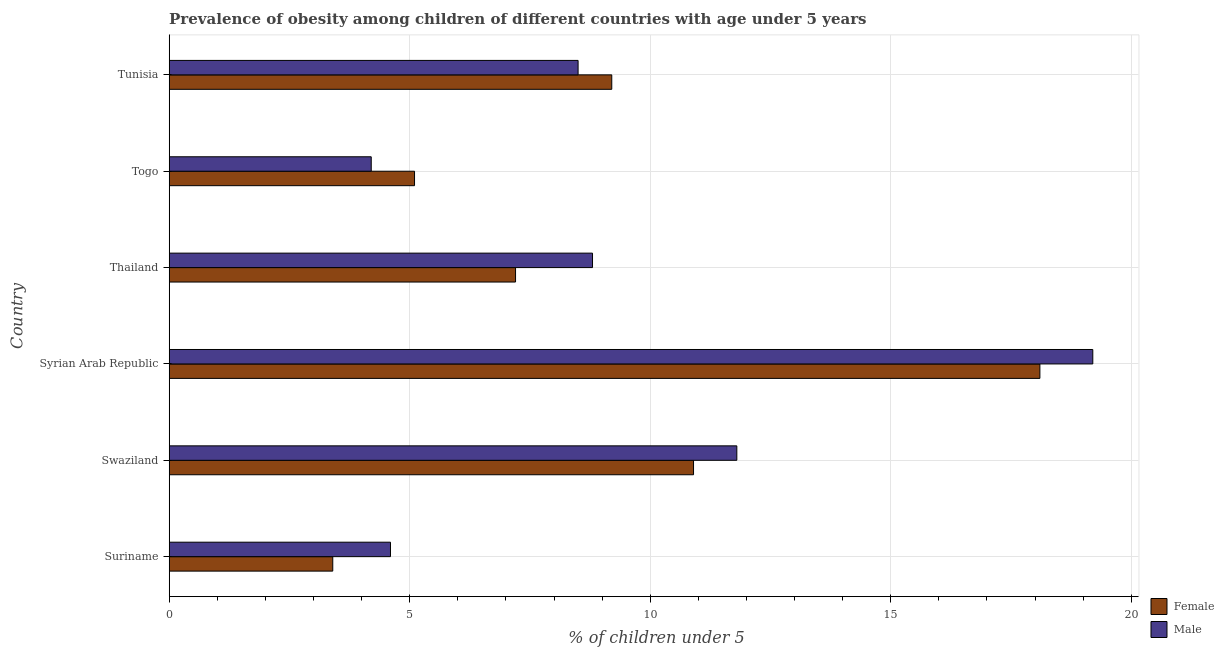How many groups of bars are there?
Make the answer very short. 6. How many bars are there on the 6th tick from the top?
Your answer should be compact. 2. How many bars are there on the 3rd tick from the bottom?
Make the answer very short. 2. What is the label of the 2nd group of bars from the top?
Your response must be concise. Togo. In how many cases, is the number of bars for a given country not equal to the number of legend labels?
Give a very brief answer. 0. What is the percentage of obese male children in Suriname?
Provide a short and direct response. 4.6. Across all countries, what is the maximum percentage of obese female children?
Make the answer very short. 18.1. Across all countries, what is the minimum percentage of obese male children?
Offer a terse response. 4.2. In which country was the percentage of obese male children maximum?
Keep it short and to the point. Syrian Arab Republic. In which country was the percentage of obese female children minimum?
Your response must be concise. Suriname. What is the total percentage of obese male children in the graph?
Make the answer very short. 57.1. What is the difference between the percentage of obese female children in Togo and that in Tunisia?
Ensure brevity in your answer.  -4.1. What is the difference between the percentage of obese male children in Suriname and the percentage of obese female children in Thailand?
Keep it short and to the point. -2.6. What is the average percentage of obese female children per country?
Offer a terse response. 8.98. What is the difference between the percentage of obese male children and percentage of obese female children in Syrian Arab Republic?
Ensure brevity in your answer.  1.1. In how many countries, is the percentage of obese female children greater than 13 %?
Offer a terse response. 1. What is the ratio of the percentage of obese female children in Syrian Arab Republic to that in Tunisia?
Make the answer very short. 1.97. What is the difference between the highest and the lowest percentage of obese female children?
Your answer should be compact. 14.7. What does the 2nd bar from the top in Suriname represents?
Ensure brevity in your answer.  Female. How many bars are there?
Offer a very short reply. 12. Are all the bars in the graph horizontal?
Provide a succinct answer. Yes. How are the legend labels stacked?
Make the answer very short. Vertical. What is the title of the graph?
Keep it short and to the point. Prevalence of obesity among children of different countries with age under 5 years. Does "Frequency of shipment arrival" appear as one of the legend labels in the graph?
Make the answer very short. No. What is the label or title of the X-axis?
Keep it short and to the point.  % of children under 5. What is the label or title of the Y-axis?
Offer a very short reply. Country. What is the  % of children under 5 in Female in Suriname?
Offer a very short reply. 3.4. What is the  % of children under 5 of Male in Suriname?
Your answer should be very brief. 4.6. What is the  % of children under 5 in Female in Swaziland?
Your answer should be compact. 10.9. What is the  % of children under 5 of Male in Swaziland?
Provide a succinct answer. 11.8. What is the  % of children under 5 in Female in Syrian Arab Republic?
Offer a terse response. 18.1. What is the  % of children under 5 of Male in Syrian Arab Republic?
Offer a very short reply. 19.2. What is the  % of children under 5 in Female in Thailand?
Make the answer very short. 7.2. What is the  % of children under 5 of Male in Thailand?
Keep it short and to the point. 8.8. What is the  % of children under 5 in Female in Togo?
Ensure brevity in your answer.  5.1. What is the  % of children under 5 of Male in Togo?
Offer a terse response. 4.2. What is the  % of children under 5 of Female in Tunisia?
Provide a succinct answer. 9.2. What is the  % of children under 5 in Male in Tunisia?
Provide a succinct answer. 8.5. Across all countries, what is the maximum  % of children under 5 of Female?
Your response must be concise. 18.1. Across all countries, what is the maximum  % of children under 5 of Male?
Offer a very short reply. 19.2. Across all countries, what is the minimum  % of children under 5 of Female?
Give a very brief answer. 3.4. Across all countries, what is the minimum  % of children under 5 of Male?
Provide a succinct answer. 4.2. What is the total  % of children under 5 in Female in the graph?
Your answer should be very brief. 53.9. What is the total  % of children under 5 of Male in the graph?
Make the answer very short. 57.1. What is the difference between the  % of children under 5 of Male in Suriname and that in Swaziland?
Make the answer very short. -7.2. What is the difference between the  % of children under 5 of Female in Suriname and that in Syrian Arab Republic?
Make the answer very short. -14.7. What is the difference between the  % of children under 5 in Male in Suriname and that in Syrian Arab Republic?
Offer a terse response. -14.6. What is the difference between the  % of children under 5 in Male in Suriname and that in Thailand?
Make the answer very short. -4.2. What is the difference between the  % of children under 5 in Male in Suriname and that in Togo?
Provide a short and direct response. 0.4. What is the difference between the  % of children under 5 of Male in Suriname and that in Tunisia?
Give a very brief answer. -3.9. What is the difference between the  % of children under 5 of Female in Swaziland and that in Syrian Arab Republic?
Offer a terse response. -7.2. What is the difference between the  % of children under 5 of Female in Swaziland and that in Thailand?
Offer a terse response. 3.7. What is the difference between the  % of children under 5 of Male in Swaziland and that in Thailand?
Provide a succinct answer. 3. What is the difference between the  % of children under 5 in Female in Swaziland and that in Togo?
Make the answer very short. 5.8. What is the difference between the  % of children under 5 in Male in Swaziland and that in Togo?
Provide a succinct answer. 7.6. What is the difference between the  % of children under 5 in Female in Syrian Arab Republic and that in Thailand?
Keep it short and to the point. 10.9. What is the difference between the  % of children under 5 of Male in Syrian Arab Republic and that in Thailand?
Keep it short and to the point. 10.4. What is the difference between the  % of children under 5 of Female in Syrian Arab Republic and that in Tunisia?
Provide a succinct answer. 8.9. What is the difference between the  % of children under 5 in Female in Thailand and that in Togo?
Ensure brevity in your answer.  2.1. What is the difference between the  % of children under 5 of Female in Togo and that in Tunisia?
Offer a very short reply. -4.1. What is the difference between the  % of children under 5 of Female in Suriname and the  % of children under 5 of Male in Swaziland?
Your response must be concise. -8.4. What is the difference between the  % of children under 5 in Female in Suriname and the  % of children under 5 in Male in Syrian Arab Republic?
Your response must be concise. -15.8. What is the difference between the  % of children under 5 of Female in Suriname and the  % of children under 5 of Male in Thailand?
Give a very brief answer. -5.4. What is the difference between the  % of children under 5 of Female in Suriname and the  % of children under 5 of Male in Tunisia?
Ensure brevity in your answer.  -5.1. What is the difference between the  % of children under 5 of Female in Swaziland and the  % of children under 5 of Male in Syrian Arab Republic?
Keep it short and to the point. -8.3. What is the difference between the  % of children under 5 of Female in Swaziland and the  % of children under 5 of Male in Tunisia?
Your response must be concise. 2.4. What is the difference between the  % of children under 5 in Female in Syrian Arab Republic and the  % of children under 5 in Male in Tunisia?
Give a very brief answer. 9.6. What is the difference between the  % of children under 5 of Female in Thailand and the  % of children under 5 of Male in Togo?
Give a very brief answer. 3. What is the difference between the  % of children under 5 of Female in Thailand and the  % of children under 5 of Male in Tunisia?
Provide a succinct answer. -1.3. What is the difference between the  % of children under 5 in Female in Togo and the  % of children under 5 in Male in Tunisia?
Your answer should be compact. -3.4. What is the average  % of children under 5 in Female per country?
Your answer should be compact. 8.98. What is the average  % of children under 5 in Male per country?
Make the answer very short. 9.52. What is the difference between the  % of children under 5 of Female and  % of children under 5 of Male in Suriname?
Offer a terse response. -1.2. What is the difference between the  % of children under 5 of Female and  % of children under 5 of Male in Syrian Arab Republic?
Offer a terse response. -1.1. What is the ratio of the  % of children under 5 in Female in Suriname to that in Swaziland?
Keep it short and to the point. 0.31. What is the ratio of the  % of children under 5 in Male in Suriname to that in Swaziland?
Your answer should be compact. 0.39. What is the ratio of the  % of children under 5 of Female in Suriname to that in Syrian Arab Republic?
Your answer should be compact. 0.19. What is the ratio of the  % of children under 5 in Male in Suriname to that in Syrian Arab Republic?
Give a very brief answer. 0.24. What is the ratio of the  % of children under 5 of Female in Suriname to that in Thailand?
Give a very brief answer. 0.47. What is the ratio of the  % of children under 5 of Male in Suriname to that in Thailand?
Ensure brevity in your answer.  0.52. What is the ratio of the  % of children under 5 of Male in Suriname to that in Togo?
Provide a succinct answer. 1.1. What is the ratio of the  % of children under 5 of Female in Suriname to that in Tunisia?
Ensure brevity in your answer.  0.37. What is the ratio of the  % of children under 5 of Male in Suriname to that in Tunisia?
Keep it short and to the point. 0.54. What is the ratio of the  % of children under 5 in Female in Swaziland to that in Syrian Arab Republic?
Provide a short and direct response. 0.6. What is the ratio of the  % of children under 5 of Male in Swaziland to that in Syrian Arab Republic?
Give a very brief answer. 0.61. What is the ratio of the  % of children under 5 in Female in Swaziland to that in Thailand?
Your answer should be very brief. 1.51. What is the ratio of the  % of children under 5 of Male in Swaziland to that in Thailand?
Ensure brevity in your answer.  1.34. What is the ratio of the  % of children under 5 in Female in Swaziland to that in Togo?
Your response must be concise. 2.14. What is the ratio of the  % of children under 5 of Male in Swaziland to that in Togo?
Your response must be concise. 2.81. What is the ratio of the  % of children under 5 of Female in Swaziland to that in Tunisia?
Give a very brief answer. 1.18. What is the ratio of the  % of children under 5 in Male in Swaziland to that in Tunisia?
Give a very brief answer. 1.39. What is the ratio of the  % of children under 5 in Female in Syrian Arab Republic to that in Thailand?
Offer a terse response. 2.51. What is the ratio of the  % of children under 5 in Male in Syrian Arab Republic to that in Thailand?
Give a very brief answer. 2.18. What is the ratio of the  % of children under 5 in Female in Syrian Arab Republic to that in Togo?
Your answer should be very brief. 3.55. What is the ratio of the  % of children under 5 in Male in Syrian Arab Republic to that in Togo?
Make the answer very short. 4.57. What is the ratio of the  % of children under 5 in Female in Syrian Arab Republic to that in Tunisia?
Your response must be concise. 1.97. What is the ratio of the  % of children under 5 of Male in Syrian Arab Republic to that in Tunisia?
Your response must be concise. 2.26. What is the ratio of the  % of children under 5 of Female in Thailand to that in Togo?
Your answer should be compact. 1.41. What is the ratio of the  % of children under 5 in Male in Thailand to that in Togo?
Provide a succinct answer. 2.1. What is the ratio of the  % of children under 5 in Female in Thailand to that in Tunisia?
Your response must be concise. 0.78. What is the ratio of the  % of children under 5 in Male in Thailand to that in Tunisia?
Provide a succinct answer. 1.04. What is the ratio of the  % of children under 5 of Female in Togo to that in Tunisia?
Keep it short and to the point. 0.55. What is the ratio of the  % of children under 5 in Male in Togo to that in Tunisia?
Ensure brevity in your answer.  0.49. What is the difference between the highest and the second highest  % of children under 5 in Female?
Your response must be concise. 7.2. What is the difference between the highest and the second highest  % of children under 5 of Male?
Your answer should be very brief. 7.4. What is the difference between the highest and the lowest  % of children under 5 of Female?
Provide a short and direct response. 14.7. What is the difference between the highest and the lowest  % of children under 5 in Male?
Give a very brief answer. 15. 